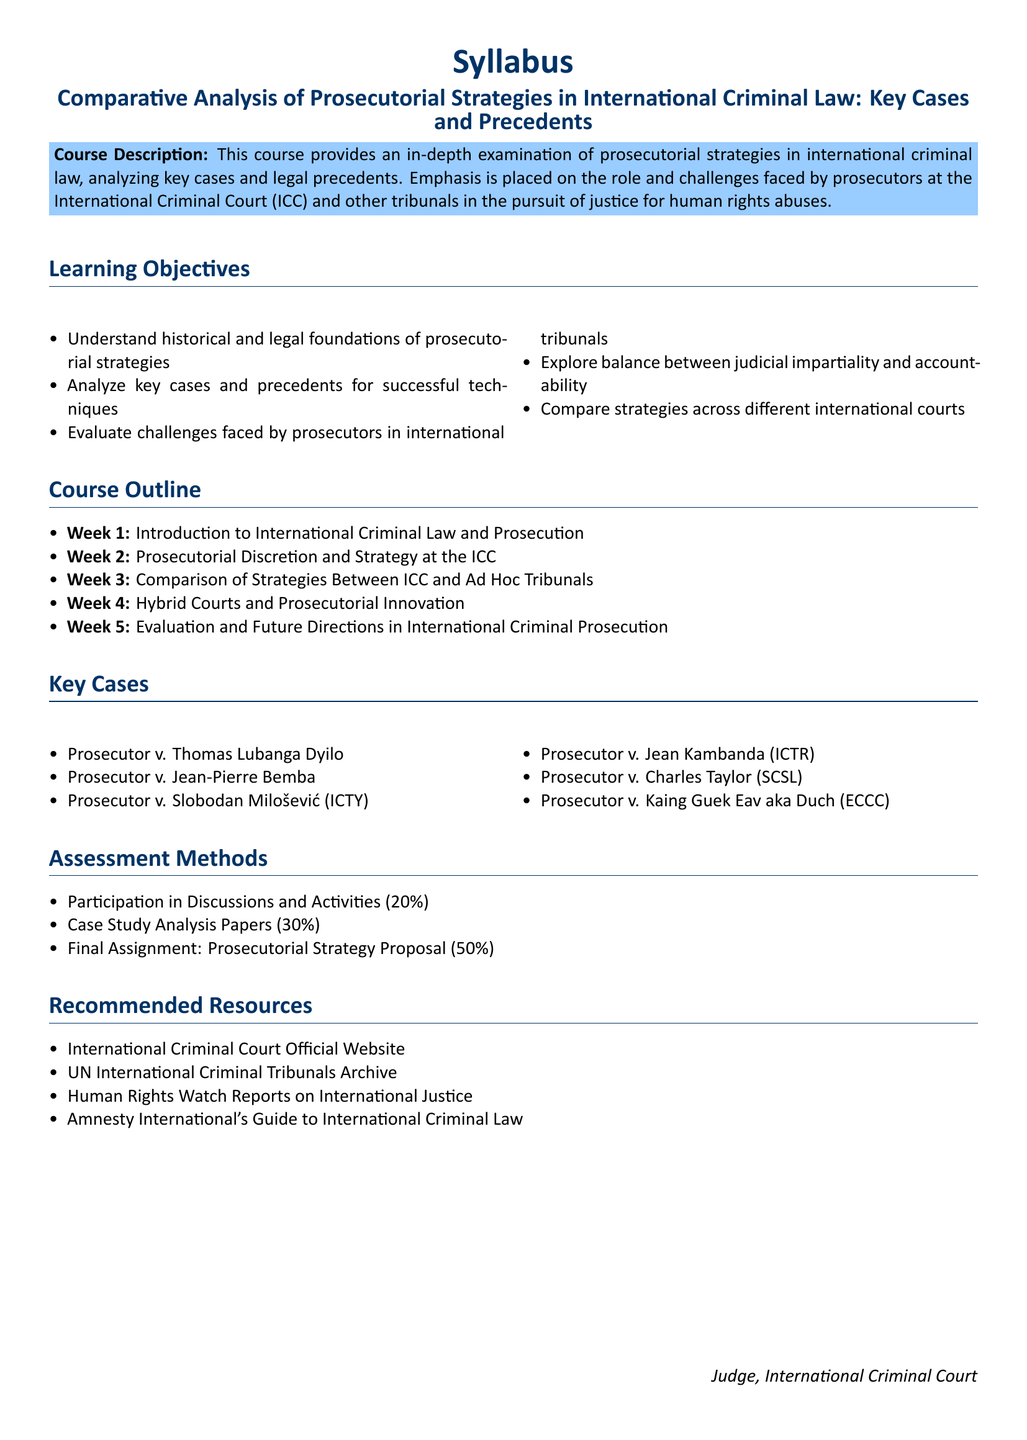what is the course title? The course title is provided in the heading section of the syllabus.
Answer: Comparative Analysis of Prosecutorial Strategies in International Criminal Law: Key Cases and Precedents what percentage of the assessment is from the final assignment? The assessment methods section lists the weight of each assessment component.
Answer: 50% which week covers hybrid courts and prosecutorial innovation? The course outline specifies the content for each week.
Answer: Week 4 name one key case in the syllabus. The key cases are listed under the key cases section.
Answer: Prosecutor v. Thomas Lubanga Dyilo what is one of the learning objectives? The learning objectives section outlines the goals of the course.
Answer: Understand historical and legal foundations of prosecutorial strategies how many weeks are there in total in the course outline? The course outline section lists the weeks of the course.
Answer: 5 what organization is suggested as a recommended resource? The recommended resources section provides sources for further reading or research.
Answer: Human Rights Watch Reports on International Justice 